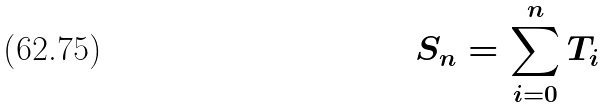Convert formula to latex. <formula><loc_0><loc_0><loc_500><loc_500>S _ { n } = \sum _ { i = 0 } ^ { n } T _ { i }</formula> 